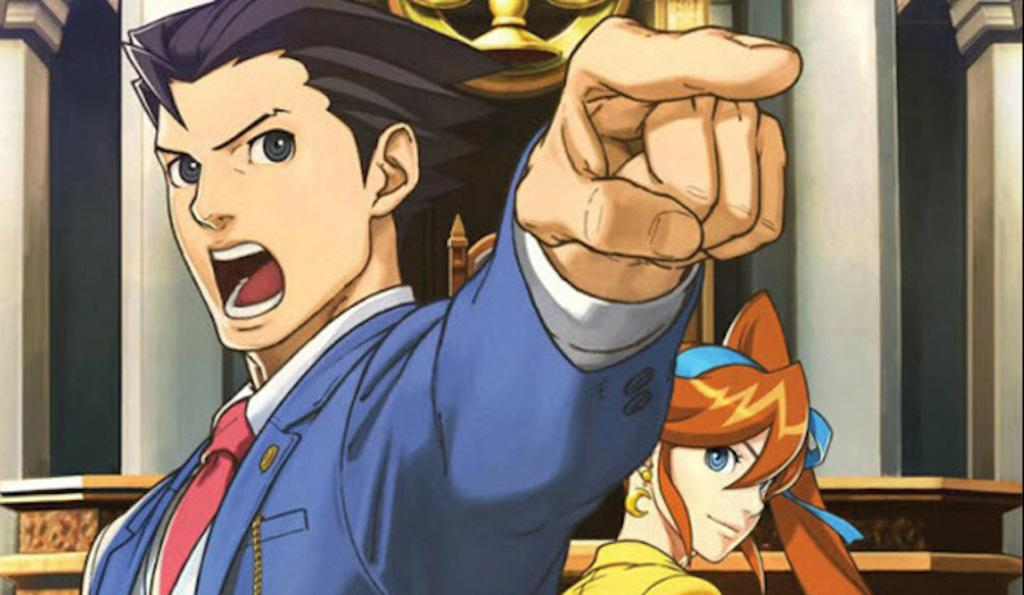What type of image is being described? The image is an animation. Who or what can be seen in the center of the image? There is a man and a lady in the center of the image. What is visible in the background of the image? There is a wall in the background of the image. What type of oil is being used by the mice in the image? There are no mice present in the image, so it is not possible to determine what type of oil they might be using. 